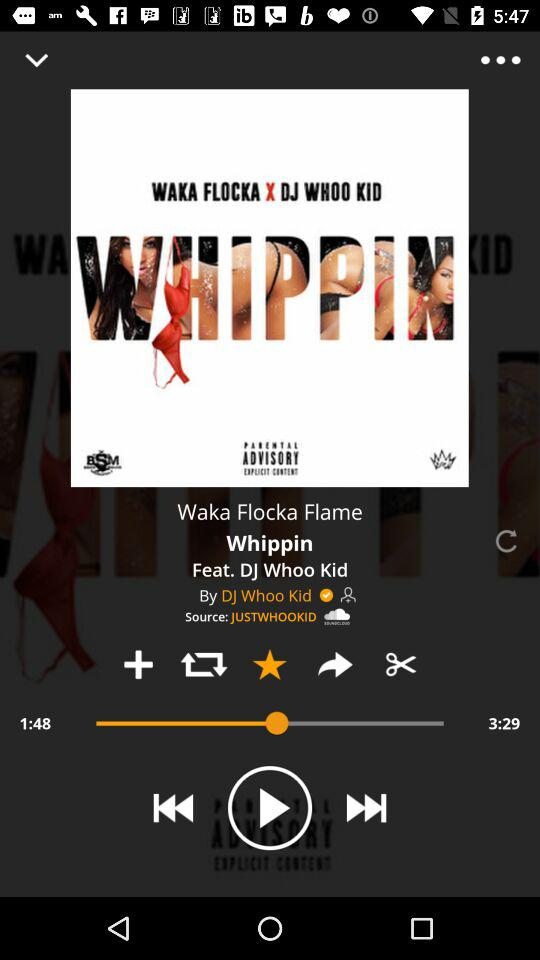How long has the song been playing? The song has been playing for 1 minute and 48 seconds. 